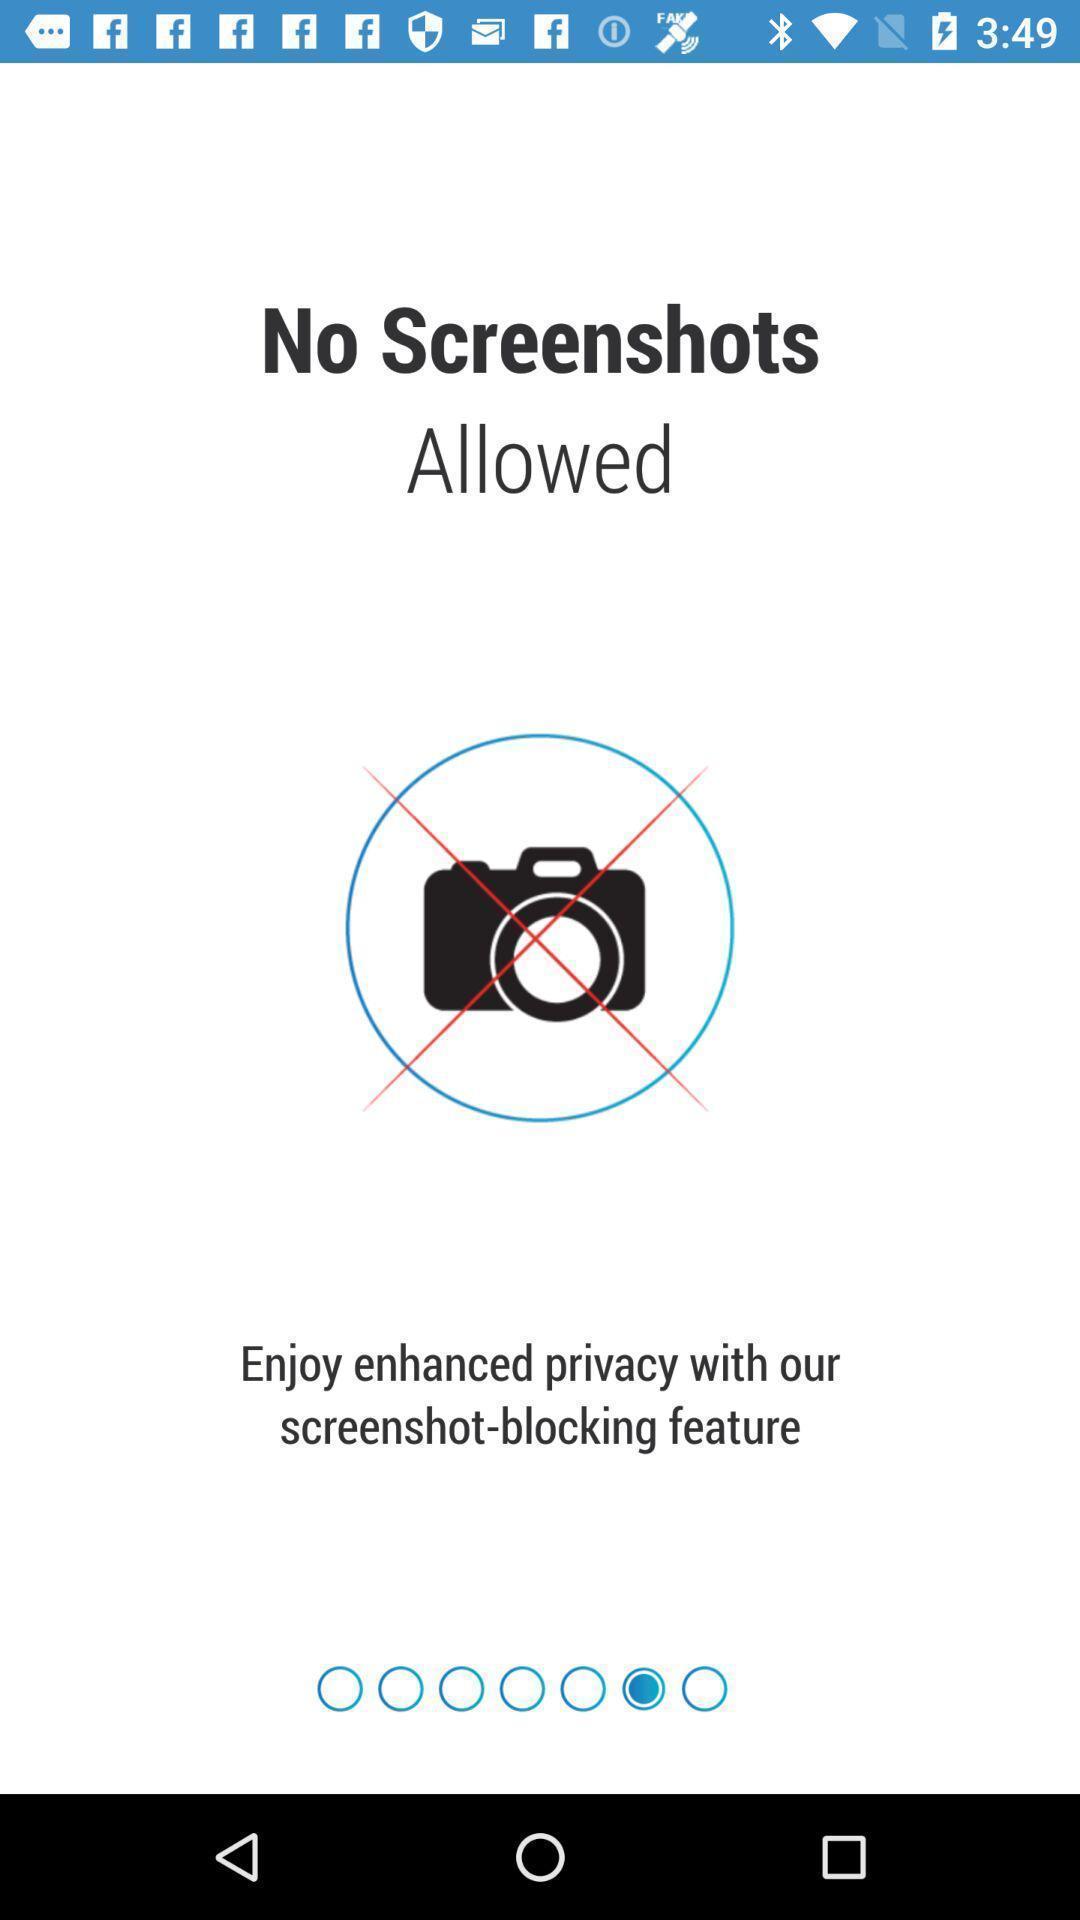Give me a narrative description of this picture. Screen displaying the disclaimer no screenshots. 